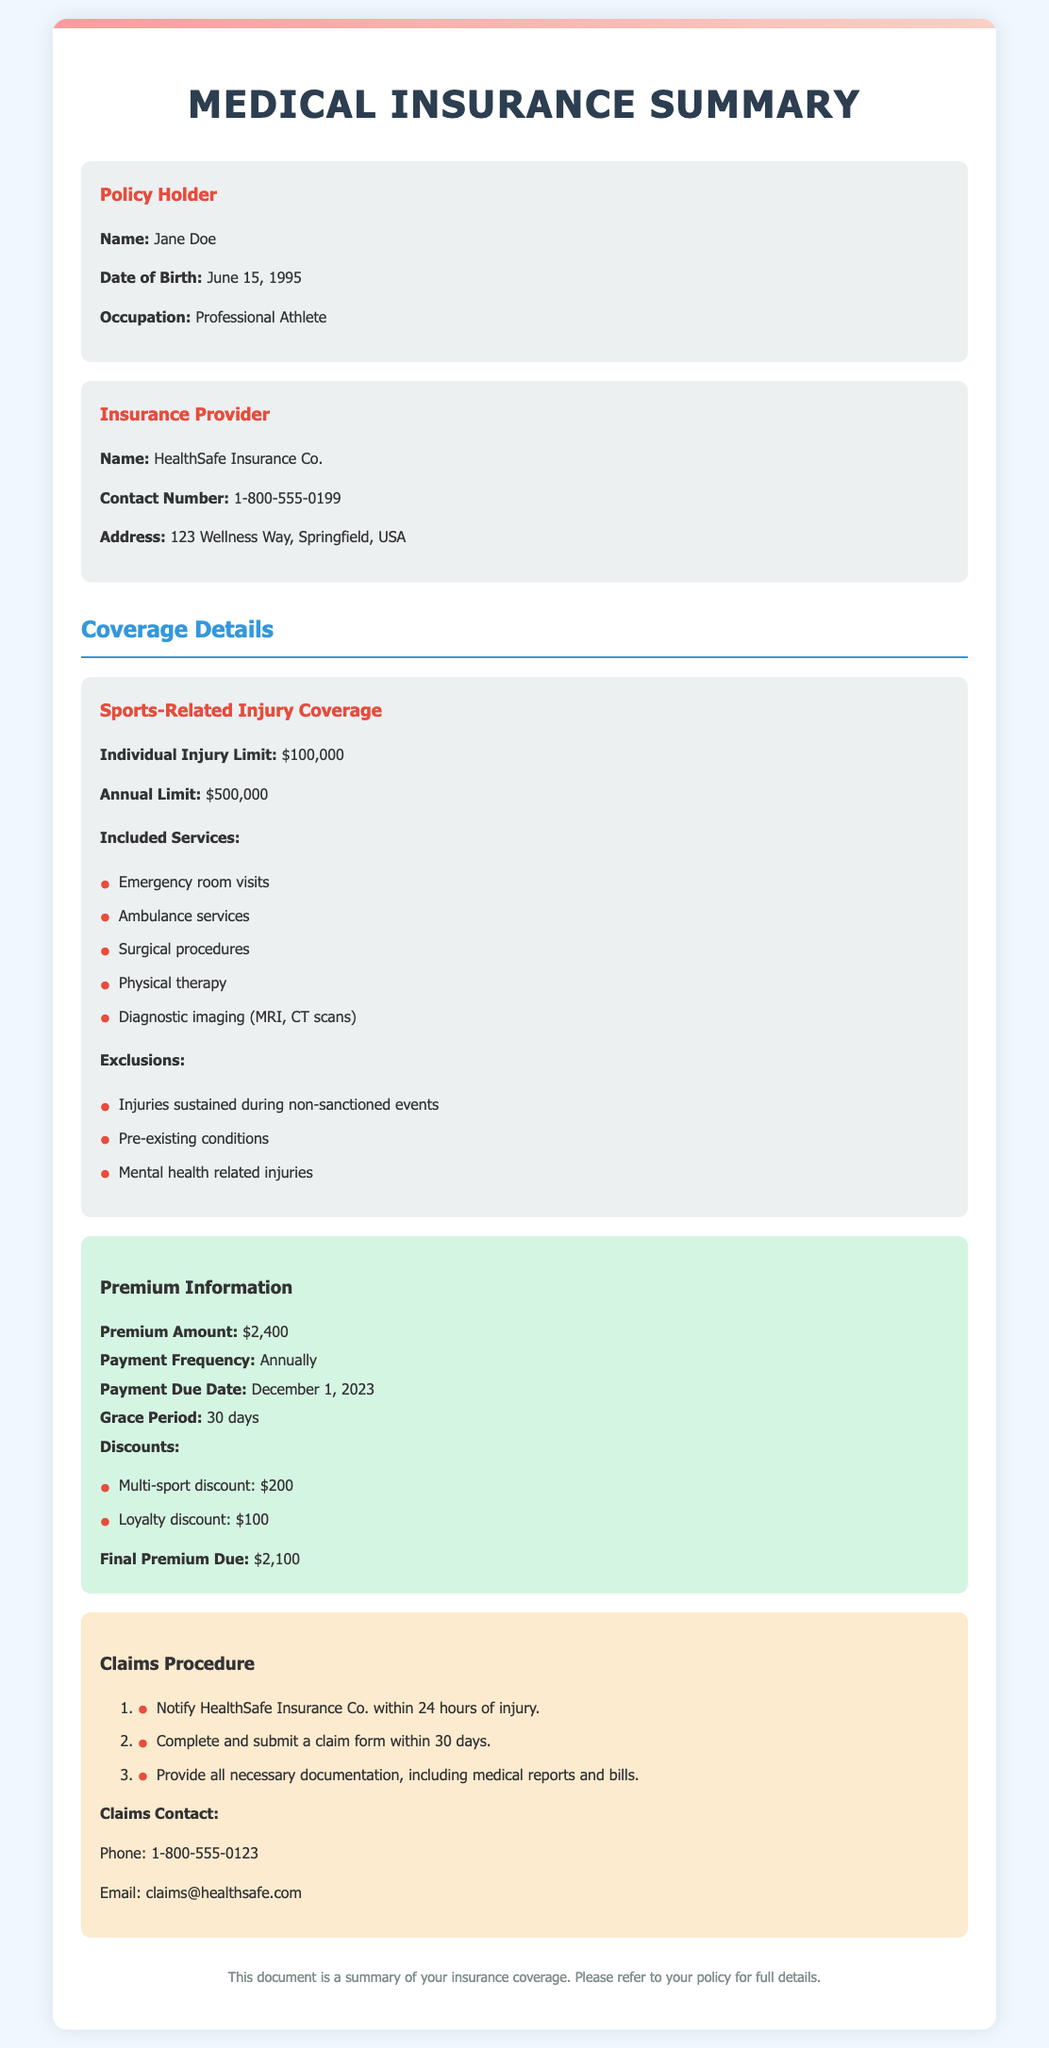What is the name of the policy holder? The name of the policy holder is stated in the document under the "Policy Holder" section.
Answer: Jane Doe What is the annual limit for sports-related injuries? The annual limit for sports-related injuries is outlined in the "Coverage Details" section of the document.
Answer: $500,000 What is the premium amount for the insurance? The premium amount is provided in the "Premium Information" section of the document.
Answer: $2,400 Which company provides the insurance policy? The insurance provider's name is mentioned in the "Insurance Provider" section of the document.
Answer: HealthSafe Insurance Co How long is the grace period for premium payment? The grace period is specified in the "Premium Information" section of the document.
Answer: 30 days What is required to be submitted within 30 days after an injury? The document details the claims procedure that includes this requirement.
Answer: Claim form What discounts are available for the premium? Discounts are listed in the "Premium Information" section, highlighting specific savings.
Answer: Multi-sport discount and Loyalty discount What should you do within 24 hours of an injury? The claims procedure outlines the necessary action to take within this timeframe.
Answer: Notify HealthSafe Insurance Co What is the final premium due after discounts? The final amount after including discounts is found in the "Premium Information" section.
Answer: $2,100 